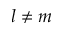Convert formula to latex. <formula><loc_0><loc_0><loc_500><loc_500>l \neq m</formula> 